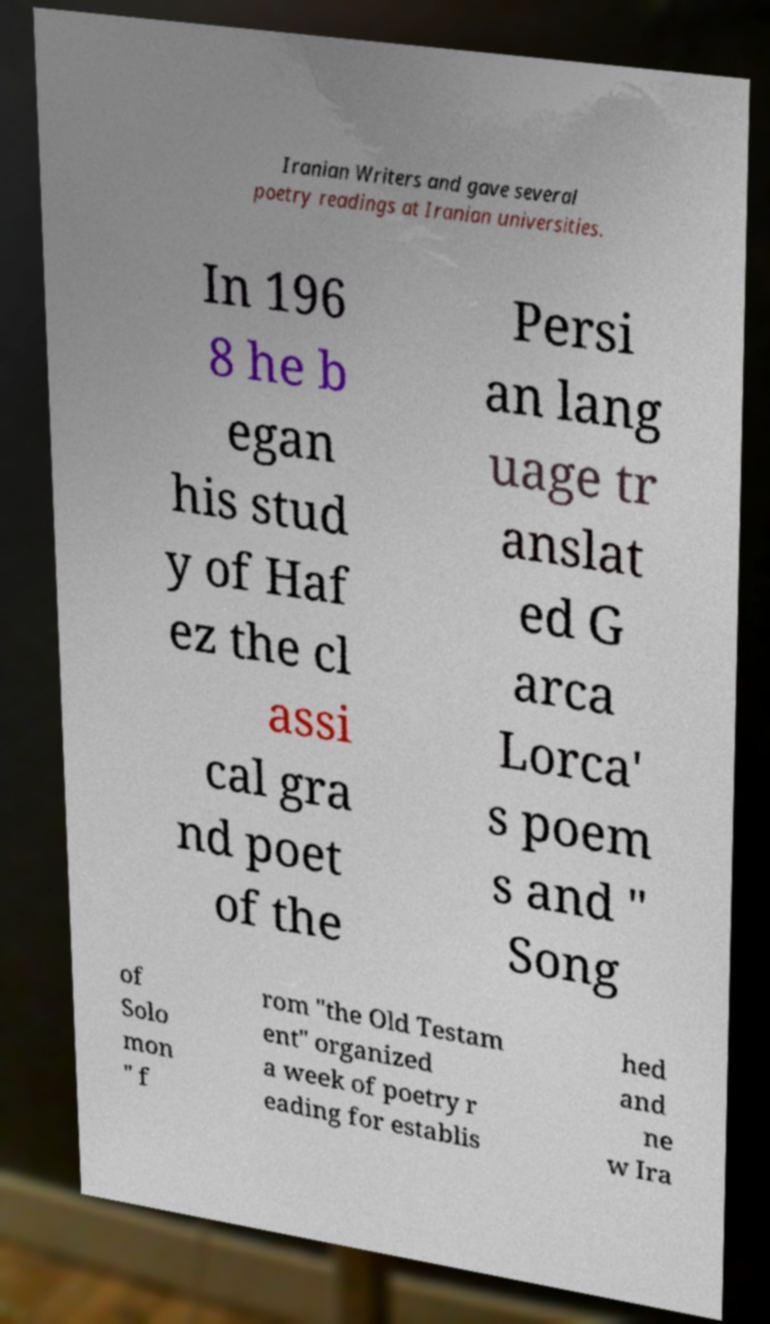Please read and relay the text visible in this image. What does it say? Iranian Writers and gave several poetry readings at Iranian universities. In 196 8 he b egan his stud y of Haf ez the cl assi cal gra nd poet of the Persi an lang uage tr anslat ed G arca Lorca' s poem s and " Song of Solo mon " f rom "the Old Testam ent" organized a week of poetry r eading for establis hed and ne w Ira 